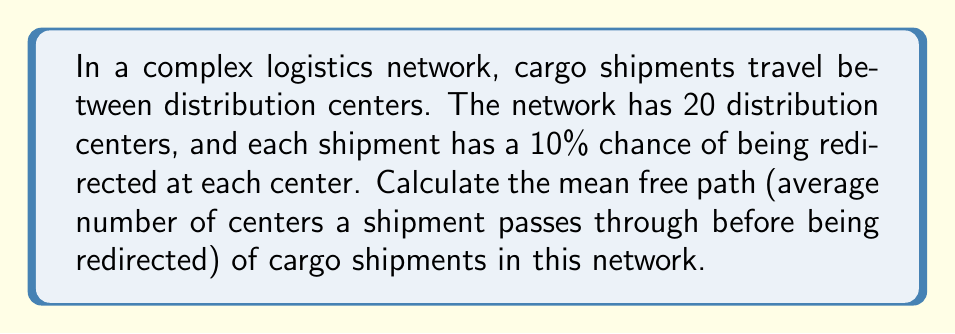Help me with this question. To solve this problem, we'll use concepts from statistical mechanics applied to logistics:

1. The probability of a shipment being redirected at each center is $p = 0.10$ or 10%.

2. The probability of a shipment not being redirected is $q = 1 - p = 0.90$ or 90%.

3. The probability of a shipment traveling through exactly $n$ centers before being redirected is given by the geometric distribution:

   $P(n) = q^{n-1} \cdot p$

4. The mean free path $\lambda$ is the expected value of this distribution:

   $\lambda = E(n) = \sum_{n=1}^{\infty} n \cdot P(n)$

5. For a geometric distribution, the mean is given by:

   $\lambda = \frac{1}{p}$

6. Substituting our value of $p$:

   $\lambda = \frac{1}{0.10} = 10$

Therefore, on average, a cargo shipment will pass through 10 distribution centers before being redirected.

Note: The total number of distribution centers (20) doesn't affect the mean free path in this case, as long as it's sufficiently large compared to the calculated mean.
Answer: 10 distribution centers 